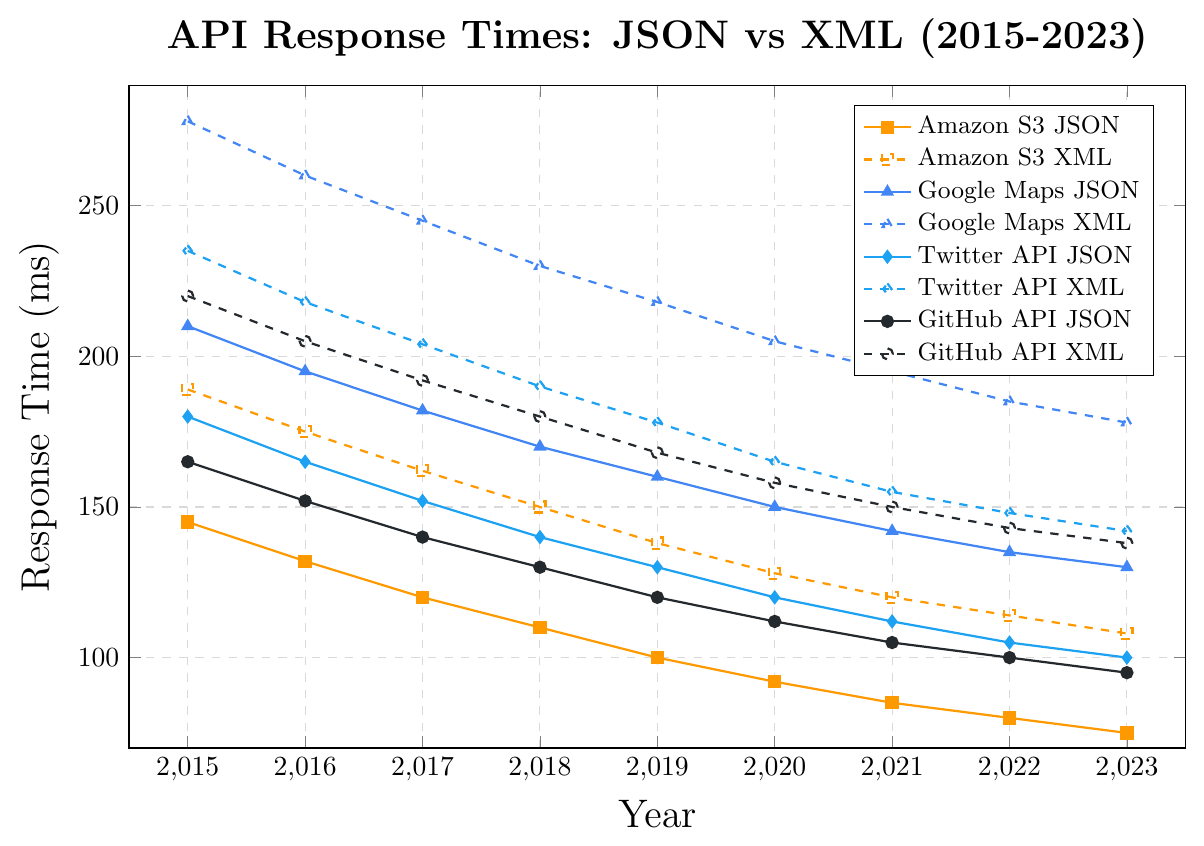Which year had the highest response time for Google Maps XML? Look for the highest point on the line representing Google Maps XML and identify the corresponding year. The highest value is 278 ms in 2015.
Answer: 2015 By how much did the response time for Twitter API JSON decrease from 2015 to 2023? Compare the response times for Twitter API JSON in 2015 and 2023. In 2015, it was 180 ms and in 2023, it was 100 ms. Subtracting 100 from 180 gives a decrease of 80 ms.
Answer: 80 ms Which API showed the smallest response time improvement for JSON payloads from 2015 to 2023? Calculate the difference in response times from 2015 to 2023 for each API with JSON payloads: Amazon S3 (145-75), Google Maps (210-130), Twitter (180-100), GitHub (165-95). The smallest improvement is for Google Maps, with a decrease of 80 ms.
Answer: Google Maps What is the average response time for GitHub API XML across all years shown? Add the response times for GitHub API XML from 2015 to 2023 (220 + 205 + 192 + 180 + 168 + 158 + 150 + 143 + 138) and divide by the number of years (9). The total is 1554, so the average is 1554/9 ≈ 172.67 ms.
Answer: 172.67 ms Compare the response times of GitHub API JSON and Twitter API XML in 2021. Which is lower and by how much? Check the response times for GitHub API JSON and Twitter API XML in 2021. GitHub API JSON is 105 ms, while Twitter API XML is 155 ms. Subtracting 105 from 155 gives 50 ms. GitHub API JSON is lower by 50 ms.
Answer: GitHub API JSON by 50 ms What trend can be observed for Amazon S3 XML response times from 2015 to 2023? Examine the response times for Amazon S3 XML from 2015 to 2023: 189, 175, 162, 150, 138, 128, 120, 114, 108. The trend is a consistent decrease over the years.
Answer: Consistent decrease In which year did the response time difference between Google Maps JSON and XML become the closest, and what was the difference? Look for the year where the difference between Google Maps JSON and XML response times is the smallest. In 2023, JSON is 130 ms and XML is 178 ms, giving a difference of 48 ms.
Answer: 2023, 48 ms 